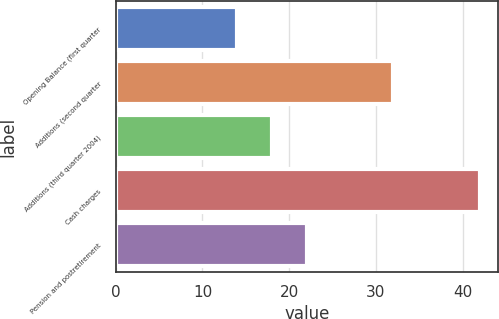Convert chart to OTSL. <chart><loc_0><loc_0><loc_500><loc_500><bar_chart><fcel>Opening Balance (first quarter<fcel>Additions (second quarter<fcel>Additions (third quarter 2004)<fcel>Cash charges<fcel>Pension and postretirement<nl><fcel>14<fcel>32<fcel>18<fcel>42<fcel>22<nl></chart> 